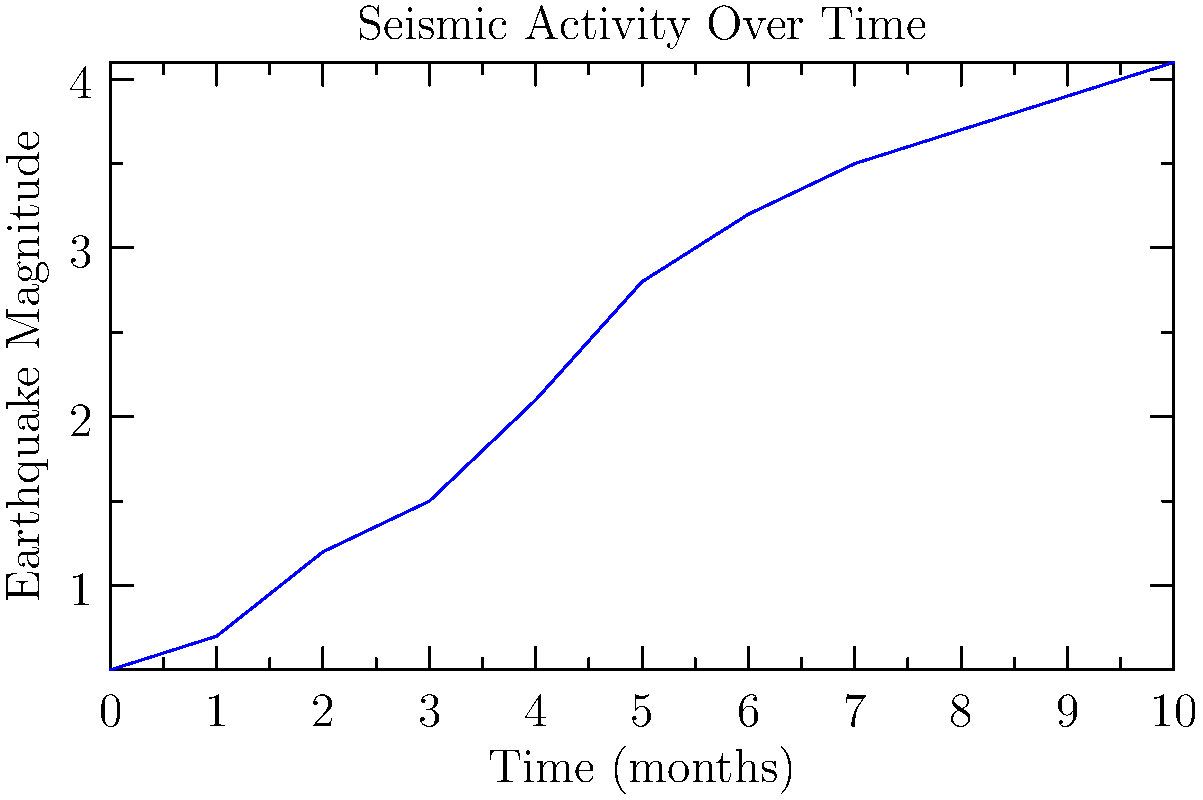Based on the graph showing seismic activity over time near the oil drilling site, what conclusion can be drawn about the potential for drilling-induced earthquakes, and what action should be recommended to the city council? To interpret the graph and draw conclusions about potential drilling-induced earthquakes, we need to follow these steps:

1. Analyze the trend:
   The graph shows a clear upward trend in earthquake magnitude over time.

2. Assess the rate of increase:
   The magnitude increases from 0.5 to 4.1 over 10 months, which is a significant rise.

3. Consider the magnitude scale:
   The Richter scale is logarithmic, meaning each whole number increase represents a tenfold increase in earthquake strength.

4. Evaluate the current magnitude:
   The latest recorded magnitude is 4.1, which is considered a light earthquake but can still cause minor damage.

5. Project future trends:
   If this trend continues, it could lead to more severe earthquakes in the future.

6. Correlate with drilling activities:
   The increase in seismic activity coincides with the timeline of drilling operations, suggesting a possible connection.

7. Apply the precautionary principle:
   Given the potential risks, it's prudent to assume a causal relationship between drilling and increased seismic activity.

8. Consider regulatory guidelines:
   Many jurisdictions have protocols for suspending operations when induced seismicity reaches certain thresholds.

9. Weigh economic and safety factors:
   Balance the economic benefits of drilling against the potential risks to public safety and infrastructure.

10. Formulate a recommendation:
    Based on the increasing trend and potential risks, it would be advisable to recommend suspending drilling operations pending further investigation and implementation of mitigation measures.
Answer: Recommend suspending drilling operations due to increasing seismic activity potentially linked to drilling. 